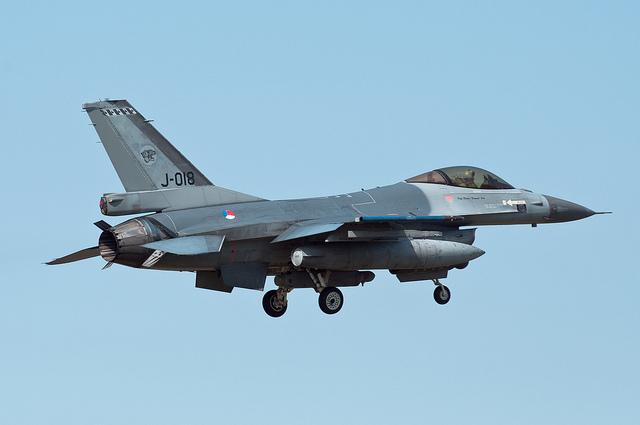What letter and number is on the plane?
Answer briefly. J-018. What kind of vehicle is shown?
Quick response, please. Jet. What is in the air?
Concise answer only. Plane. What does the pilot have on his head?
Answer briefly. Helmet. 